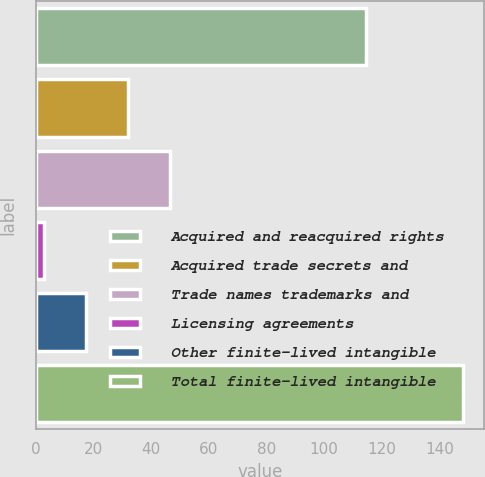Convert chart. <chart><loc_0><loc_0><loc_500><loc_500><bar_chart><fcel>Acquired and reacquired rights<fcel>Acquired trade secrets and<fcel>Trade names trademarks and<fcel>Licensing agreements<fcel>Other finite-lived intangible<fcel>Total finite-lived intangible<nl><fcel>114.5<fcel>31.86<fcel>46.39<fcel>2.8<fcel>17.33<fcel>148.1<nl></chart> 